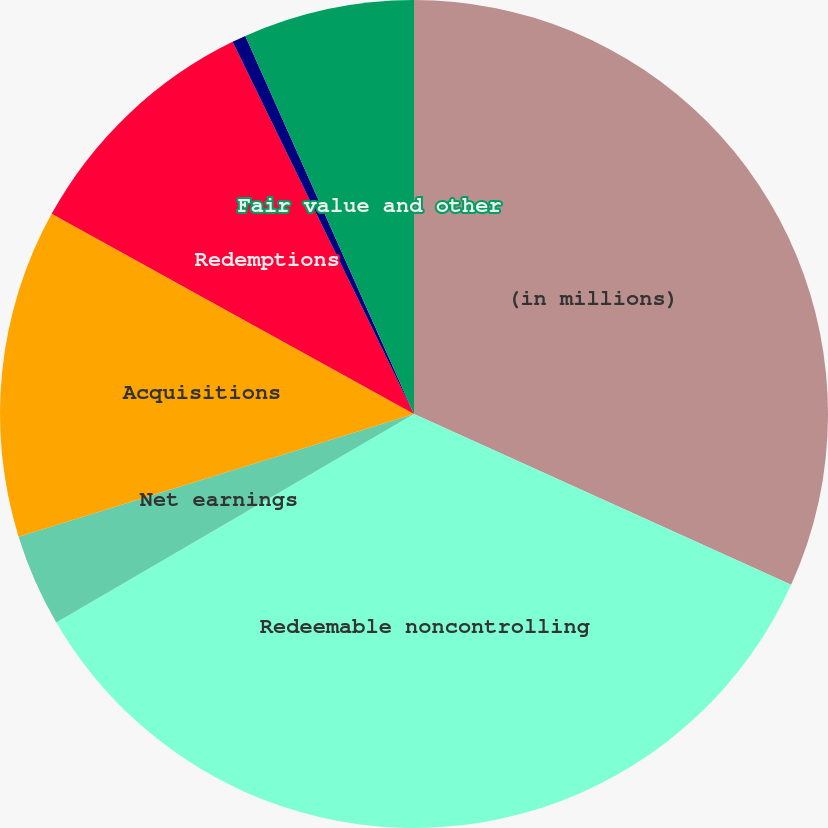<chart> <loc_0><loc_0><loc_500><loc_500><pie_chart><fcel>(in millions)<fcel>Redeemable noncontrolling<fcel>Net earnings<fcel>Acquisitions<fcel>Redemptions<fcel>Distributions<fcel>Fair value and other<nl><fcel>31.77%<fcel>34.84%<fcel>3.61%<fcel>12.82%<fcel>9.75%<fcel>0.54%<fcel>6.68%<nl></chart> 